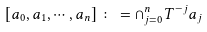<formula> <loc_0><loc_0><loc_500><loc_500>\left [ a _ { 0 } , a _ { 1 } , \cdots , a _ { n } \right ] \colon = \cap _ { j = 0 } ^ { n } T ^ { - j } a _ { j }</formula> 